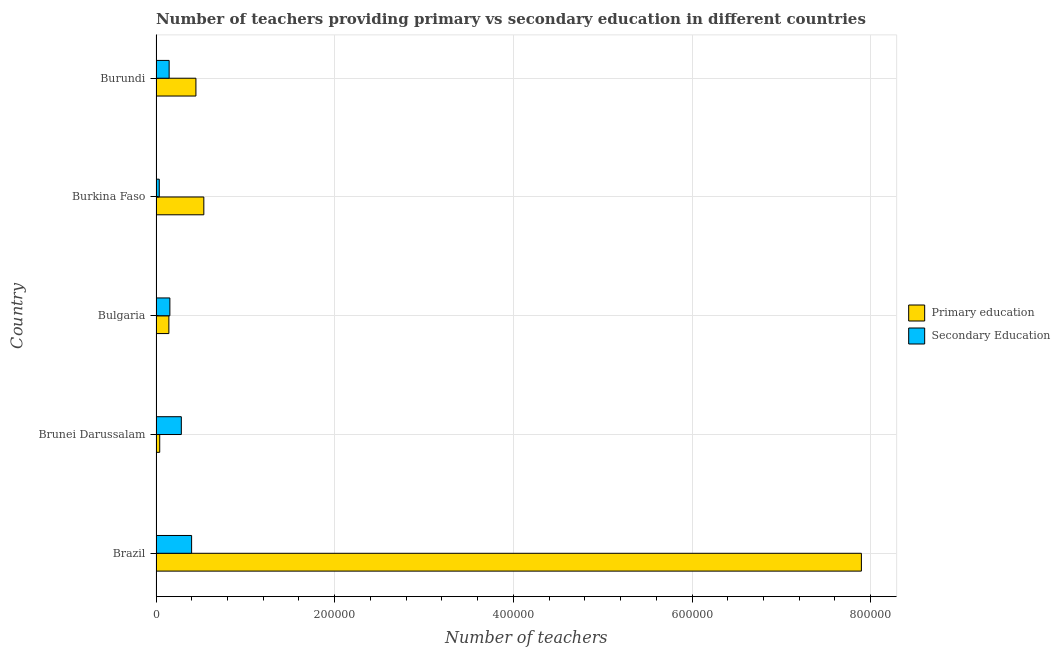How many different coloured bars are there?
Make the answer very short. 2. Are the number of bars per tick equal to the number of legend labels?
Your answer should be compact. Yes. How many bars are there on the 2nd tick from the bottom?
Make the answer very short. 2. What is the label of the 5th group of bars from the top?
Make the answer very short. Brazil. In how many cases, is the number of bars for a given country not equal to the number of legend labels?
Give a very brief answer. 0. What is the number of secondary teachers in Bulgaria?
Give a very brief answer. 1.55e+04. Across all countries, what is the maximum number of primary teachers?
Make the answer very short. 7.90e+05. Across all countries, what is the minimum number of primary teachers?
Offer a terse response. 4146. In which country was the number of primary teachers minimum?
Ensure brevity in your answer.  Brunei Darussalam. What is the total number of secondary teachers in the graph?
Keep it short and to the point. 1.02e+05. What is the difference between the number of primary teachers in Brunei Darussalam and that in Burkina Faso?
Make the answer very short. -4.94e+04. What is the difference between the number of secondary teachers in Bulgaria and the number of primary teachers in Brunei Darussalam?
Offer a very short reply. 1.14e+04. What is the average number of primary teachers per country?
Provide a short and direct response. 1.81e+05. What is the difference between the number of primary teachers and number of secondary teachers in Brazil?
Ensure brevity in your answer.  7.50e+05. In how many countries, is the number of primary teachers greater than 600000 ?
Offer a terse response. 1. What is the ratio of the number of primary teachers in Brunei Darussalam to that in Burundi?
Make the answer very short. 0.09. What is the difference between the highest and the second highest number of primary teachers?
Provide a short and direct response. 7.36e+05. What is the difference between the highest and the lowest number of secondary teachers?
Your response must be concise. 3.62e+04. In how many countries, is the number of secondary teachers greater than the average number of secondary teachers taken over all countries?
Make the answer very short. 2. Is the sum of the number of primary teachers in Brazil and Burkina Faso greater than the maximum number of secondary teachers across all countries?
Give a very brief answer. Yes. What does the 2nd bar from the top in Brunei Darussalam represents?
Give a very brief answer. Primary education. What does the 1st bar from the bottom in Bulgaria represents?
Make the answer very short. Primary education. Are all the bars in the graph horizontal?
Your answer should be compact. Yes. What is the difference between two consecutive major ticks on the X-axis?
Ensure brevity in your answer.  2.00e+05. Does the graph contain grids?
Offer a terse response. Yes. Where does the legend appear in the graph?
Provide a short and direct response. Center right. How many legend labels are there?
Your answer should be compact. 2. What is the title of the graph?
Give a very brief answer. Number of teachers providing primary vs secondary education in different countries. What is the label or title of the X-axis?
Offer a very short reply. Number of teachers. What is the Number of teachers in Primary education in Brazil?
Provide a short and direct response. 7.90e+05. What is the Number of teachers of Secondary Education in Brazil?
Ensure brevity in your answer.  3.98e+04. What is the Number of teachers of Primary education in Brunei Darussalam?
Your answer should be very brief. 4146. What is the Number of teachers of Secondary Education in Brunei Darussalam?
Ensure brevity in your answer.  2.83e+04. What is the Number of teachers in Primary education in Bulgaria?
Offer a terse response. 1.44e+04. What is the Number of teachers of Secondary Education in Bulgaria?
Your answer should be compact. 1.55e+04. What is the Number of teachers of Primary education in Burkina Faso?
Give a very brief answer. 5.35e+04. What is the Number of teachers in Secondary Education in Burkina Faso?
Your response must be concise. 3624. What is the Number of teachers of Primary education in Burundi?
Keep it short and to the point. 4.47e+04. What is the Number of teachers of Secondary Education in Burundi?
Give a very brief answer. 1.47e+04. Across all countries, what is the maximum Number of teachers of Primary education?
Offer a very short reply. 7.90e+05. Across all countries, what is the maximum Number of teachers in Secondary Education?
Offer a very short reply. 3.98e+04. Across all countries, what is the minimum Number of teachers in Primary education?
Provide a succinct answer. 4146. Across all countries, what is the minimum Number of teachers in Secondary Education?
Give a very brief answer. 3624. What is the total Number of teachers of Primary education in the graph?
Ensure brevity in your answer.  9.06e+05. What is the total Number of teachers in Secondary Education in the graph?
Make the answer very short. 1.02e+05. What is the difference between the Number of teachers in Primary education in Brazil and that in Brunei Darussalam?
Your response must be concise. 7.85e+05. What is the difference between the Number of teachers in Secondary Education in Brazil and that in Brunei Darussalam?
Provide a succinct answer. 1.15e+04. What is the difference between the Number of teachers in Primary education in Brazil and that in Bulgaria?
Provide a short and direct response. 7.75e+05. What is the difference between the Number of teachers of Secondary Education in Brazil and that in Bulgaria?
Your answer should be compact. 2.43e+04. What is the difference between the Number of teachers of Primary education in Brazil and that in Burkina Faso?
Your response must be concise. 7.36e+05. What is the difference between the Number of teachers in Secondary Education in Brazil and that in Burkina Faso?
Your answer should be very brief. 3.62e+04. What is the difference between the Number of teachers in Primary education in Brazil and that in Burundi?
Your answer should be very brief. 7.45e+05. What is the difference between the Number of teachers of Secondary Education in Brazil and that in Burundi?
Keep it short and to the point. 2.52e+04. What is the difference between the Number of teachers of Primary education in Brunei Darussalam and that in Bulgaria?
Your answer should be compact. -1.02e+04. What is the difference between the Number of teachers in Secondary Education in Brunei Darussalam and that in Bulgaria?
Make the answer very short. 1.28e+04. What is the difference between the Number of teachers in Primary education in Brunei Darussalam and that in Burkina Faso?
Provide a succinct answer. -4.94e+04. What is the difference between the Number of teachers in Secondary Education in Brunei Darussalam and that in Burkina Faso?
Your response must be concise. 2.47e+04. What is the difference between the Number of teachers of Primary education in Brunei Darussalam and that in Burundi?
Provide a short and direct response. -4.05e+04. What is the difference between the Number of teachers in Secondary Education in Brunei Darussalam and that in Burundi?
Keep it short and to the point. 1.37e+04. What is the difference between the Number of teachers of Primary education in Bulgaria and that in Burkina Faso?
Your answer should be very brief. -3.91e+04. What is the difference between the Number of teachers in Secondary Education in Bulgaria and that in Burkina Faso?
Make the answer very short. 1.19e+04. What is the difference between the Number of teachers in Primary education in Bulgaria and that in Burundi?
Your response must be concise. -3.03e+04. What is the difference between the Number of teachers of Secondary Education in Bulgaria and that in Burundi?
Make the answer very short. 821. What is the difference between the Number of teachers of Primary education in Burkina Faso and that in Burundi?
Your response must be concise. 8843. What is the difference between the Number of teachers of Secondary Education in Burkina Faso and that in Burundi?
Keep it short and to the point. -1.11e+04. What is the difference between the Number of teachers in Primary education in Brazil and the Number of teachers in Secondary Education in Brunei Darussalam?
Offer a very short reply. 7.61e+05. What is the difference between the Number of teachers of Primary education in Brazil and the Number of teachers of Secondary Education in Bulgaria?
Your answer should be compact. 7.74e+05. What is the difference between the Number of teachers of Primary education in Brazil and the Number of teachers of Secondary Education in Burkina Faso?
Offer a terse response. 7.86e+05. What is the difference between the Number of teachers in Primary education in Brazil and the Number of teachers in Secondary Education in Burundi?
Provide a succinct answer. 7.75e+05. What is the difference between the Number of teachers of Primary education in Brunei Darussalam and the Number of teachers of Secondary Education in Bulgaria?
Your answer should be very brief. -1.14e+04. What is the difference between the Number of teachers in Primary education in Brunei Darussalam and the Number of teachers in Secondary Education in Burkina Faso?
Offer a very short reply. 522. What is the difference between the Number of teachers of Primary education in Brunei Darussalam and the Number of teachers of Secondary Education in Burundi?
Your answer should be very brief. -1.05e+04. What is the difference between the Number of teachers of Primary education in Bulgaria and the Number of teachers of Secondary Education in Burkina Faso?
Keep it short and to the point. 1.08e+04. What is the difference between the Number of teachers in Primary education in Bulgaria and the Number of teachers in Secondary Education in Burundi?
Your answer should be very brief. -295. What is the difference between the Number of teachers of Primary education in Burkina Faso and the Number of teachers of Secondary Education in Burundi?
Give a very brief answer. 3.88e+04. What is the average Number of teachers in Primary education per country?
Offer a very short reply. 1.81e+05. What is the average Number of teachers in Secondary Education per country?
Your answer should be compact. 2.04e+04. What is the difference between the Number of teachers of Primary education and Number of teachers of Secondary Education in Brazil?
Offer a terse response. 7.50e+05. What is the difference between the Number of teachers in Primary education and Number of teachers in Secondary Education in Brunei Darussalam?
Ensure brevity in your answer.  -2.42e+04. What is the difference between the Number of teachers of Primary education and Number of teachers of Secondary Education in Bulgaria?
Provide a succinct answer. -1116. What is the difference between the Number of teachers in Primary education and Number of teachers in Secondary Education in Burkina Faso?
Offer a terse response. 4.99e+04. What is the difference between the Number of teachers of Primary education and Number of teachers of Secondary Education in Burundi?
Offer a very short reply. 3.00e+04. What is the ratio of the Number of teachers of Primary education in Brazil to that in Brunei Darussalam?
Provide a short and direct response. 190.44. What is the ratio of the Number of teachers of Secondary Education in Brazil to that in Brunei Darussalam?
Offer a very short reply. 1.41. What is the ratio of the Number of teachers in Primary education in Brazil to that in Bulgaria?
Ensure brevity in your answer.  54.88. What is the ratio of the Number of teachers in Secondary Education in Brazil to that in Bulgaria?
Offer a very short reply. 2.57. What is the ratio of the Number of teachers in Primary education in Brazil to that in Burkina Faso?
Your answer should be compact. 14.76. What is the ratio of the Number of teachers of Secondary Education in Brazil to that in Burkina Faso?
Your answer should be very brief. 10.99. What is the ratio of the Number of teachers in Primary education in Brazil to that in Burundi?
Offer a very short reply. 17.68. What is the ratio of the Number of teachers in Secondary Education in Brazil to that in Burundi?
Offer a terse response. 2.71. What is the ratio of the Number of teachers of Primary education in Brunei Darussalam to that in Bulgaria?
Ensure brevity in your answer.  0.29. What is the ratio of the Number of teachers in Secondary Education in Brunei Darussalam to that in Bulgaria?
Make the answer very short. 1.83. What is the ratio of the Number of teachers in Primary education in Brunei Darussalam to that in Burkina Faso?
Your response must be concise. 0.08. What is the ratio of the Number of teachers of Secondary Education in Brunei Darussalam to that in Burkina Faso?
Offer a very short reply. 7.82. What is the ratio of the Number of teachers in Primary education in Brunei Darussalam to that in Burundi?
Give a very brief answer. 0.09. What is the ratio of the Number of teachers of Secondary Education in Brunei Darussalam to that in Burundi?
Ensure brevity in your answer.  1.93. What is the ratio of the Number of teachers in Primary education in Bulgaria to that in Burkina Faso?
Your answer should be very brief. 0.27. What is the ratio of the Number of teachers of Secondary Education in Bulgaria to that in Burkina Faso?
Keep it short and to the point. 4.28. What is the ratio of the Number of teachers in Primary education in Bulgaria to that in Burundi?
Offer a very short reply. 0.32. What is the ratio of the Number of teachers in Secondary Education in Bulgaria to that in Burundi?
Your response must be concise. 1.06. What is the ratio of the Number of teachers of Primary education in Burkina Faso to that in Burundi?
Make the answer very short. 1.2. What is the ratio of the Number of teachers of Secondary Education in Burkina Faso to that in Burundi?
Your answer should be compact. 0.25. What is the difference between the highest and the second highest Number of teachers in Primary education?
Offer a very short reply. 7.36e+05. What is the difference between the highest and the second highest Number of teachers of Secondary Education?
Give a very brief answer. 1.15e+04. What is the difference between the highest and the lowest Number of teachers of Primary education?
Your answer should be compact. 7.85e+05. What is the difference between the highest and the lowest Number of teachers of Secondary Education?
Your response must be concise. 3.62e+04. 